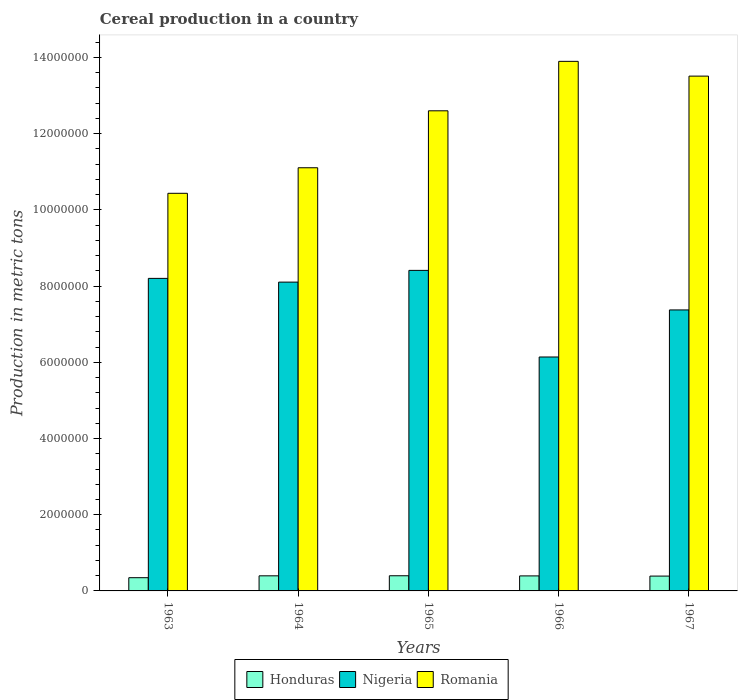Are the number of bars per tick equal to the number of legend labels?
Provide a succinct answer. Yes. Are the number of bars on each tick of the X-axis equal?
Make the answer very short. Yes. How many bars are there on the 5th tick from the left?
Offer a very short reply. 3. What is the total cereal production in Nigeria in 1963?
Your answer should be compact. 8.20e+06. Across all years, what is the maximum total cereal production in Nigeria?
Offer a very short reply. 8.41e+06. Across all years, what is the minimum total cereal production in Honduras?
Offer a very short reply. 3.47e+05. In which year was the total cereal production in Romania maximum?
Give a very brief answer. 1966. In which year was the total cereal production in Honduras minimum?
Your answer should be very brief. 1963. What is the total total cereal production in Honduras in the graph?
Provide a succinct answer. 1.93e+06. What is the difference between the total cereal production in Romania in 1964 and that in 1967?
Make the answer very short. -2.40e+06. What is the difference between the total cereal production in Nigeria in 1965 and the total cereal production in Honduras in 1963?
Make the answer very short. 8.07e+06. What is the average total cereal production in Nigeria per year?
Offer a terse response. 7.65e+06. In the year 1967, what is the difference between the total cereal production in Honduras and total cereal production in Nigeria?
Give a very brief answer. -6.99e+06. What is the ratio of the total cereal production in Honduras in 1965 to that in 1967?
Provide a succinct answer. 1.02. Is the difference between the total cereal production in Honduras in 1966 and 1967 greater than the difference between the total cereal production in Nigeria in 1966 and 1967?
Ensure brevity in your answer.  Yes. What is the difference between the highest and the second highest total cereal production in Honduras?
Provide a succinct answer. 1847. What is the difference between the highest and the lowest total cereal production in Nigeria?
Ensure brevity in your answer.  2.27e+06. In how many years, is the total cereal production in Honduras greater than the average total cereal production in Honduras taken over all years?
Offer a terse response. 4. What does the 3rd bar from the left in 1967 represents?
Provide a succinct answer. Romania. What does the 2nd bar from the right in 1964 represents?
Provide a short and direct response. Nigeria. Are all the bars in the graph horizontal?
Offer a terse response. No. Are the values on the major ticks of Y-axis written in scientific E-notation?
Ensure brevity in your answer.  No. How many legend labels are there?
Your answer should be compact. 3. What is the title of the graph?
Offer a very short reply. Cereal production in a country. Does "Mozambique" appear as one of the legend labels in the graph?
Your answer should be very brief. No. What is the label or title of the X-axis?
Offer a very short reply. Years. What is the label or title of the Y-axis?
Provide a succinct answer. Production in metric tons. What is the Production in metric tons of Honduras in 1963?
Provide a succinct answer. 3.47e+05. What is the Production in metric tons of Nigeria in 1963?
Provide a succinct answer. 8.20e+06. What is the Production in metric tons of Romania in 1963?
Offer a very short reply. 1.04e+07. What is the Production in metric tons of Honduras in 1964?
Provide a succinct answer. 3.96e+05. What is the Production in metric tons of Nigeria in 1964?
Keep it short and to the point. 8.10e+06. What is the Production in metric tons in Romania in 1964?
Make the answer very short. 1.11e+07. What is the Production in metric tons of Honduras in 1965?
Offer a very short reply. 3.98e+05. What is the Production in metric tons in Nigeria in 1965?
Your answer should be very brief. 8.41e+06. What is the Production in metric tons in Romania in 1965?
Ensure brevity in your answer.  1.26e+07. What is the Production in metric tons of Honduras in 1966?
Provide a succinct answer. 3.94e+05. What is the Production in metric tons of Nigeria in 1966?
Ensure brevity in your answer.  6.14e+06. What is the Production in metric tons of Romania in 1966?
Offer a terse response. 1.39e+07. What is the Production in metric tons of Honduras in 1967?
Your answer should be compact. 3.89e+05. What is the Production in metric tons of Nigeria in 1967?
Your answer should be very brief. 7.38e+06. What is the Production in metric tons in Romania in 1967?
Provide a short and direct response. 1.35e+07. Across all years, what is the maximum Production in metric tons in Honduras?
Offer a terse response. 3.98e+05. Across all years, what is the maximum Production in metric tons in Nigeria?
Provide a succinct answer. 8.41e+06. Across all years, what is the maximum Production in metric tons in Romania?
Offer a very short reply. 1.39e+07. Across all years, what is the minimum Production in metric tons in Honduras?
Provide a succinct answer. 3.47e+05. Across all years, what is the minimum Production in metric tons of Nigeria?
Make the answer very short. 6.14e+06. Across all years, what is the minimum Production in metric tons of Romania?
Ensure brevity in your answer.  1.04e+07. What is the total Production in metric tons of Honduras in the graph?
Provide a succinct answer. 1.93e+06. What is the total Production in metric tons in Nigeria in the graph?
Make the answer very short. 3.82e+07. What is the total Production in metric tons in Romania in the graph?
Ensure brevity in your answer.  6.16e+07. What is the difference between the Production in metric tons of Honduras in 1963 and that in 1964?
Offer a very short reply. -4.91e+04. What is the difference between the Production in metric tons of Nigeria in 1963 and that in 1964?
Provide a succinct answer. 9.80e+04. What is the difference between the Production in metric tons of Romania in 1963 and that in 1964?
Offer a terse response. -6.71e+05. What is the difference between the Production in metric tons of Honduras in 1963 and that in 1965?
Provide a short and direct response. -5.09e+04. What is the difference between the Production in metric tons in Nigeria in 1963 and that in 1965?
Ensure brevity in your answer.  -2.10e+05. What is the difference between the Production in metric tons in Romania in 1963 and that in 1965?
Give a very brief answer. -2.17e+06. What is the difference between the Production in metric tons in Honduras in 1963 and that in 1966?
Offer a terse response. -4.71e+04. What is the difference between the Production in metric tons of Nigeria in 1963 and that in 1966?
Your response must be concise. 2.06e+06. What is the difference between the Production in metric tons of Romania in 1963 and that in 1966?
Make the answer very short. -3.46e+06. What is the difference between the Production in metric tons in Honduras in 1963 and that in 1967?
Ensure brevity in your answer.  -4.22e+04. What is the difference between the Production in metric tons in Nigeria in 1963 and that in 1967?
Your answer should be very brief. 8.28e+05. What is the difference between the Production in metric tons of Romania in 1963 and that in 1967?
Give a very brief answer. -3.08e+06. What is the difference between the Production in metric tons of Honduras in 1964 and that in 1965?
Provide a short and direct response. -1847. What is the difference between the Production in metric tons of Nigeria in 1964 and that in 1965?
Offer a terse response. -3.08e+05. What is the difference between the Production in metric tons in Romania in 1964 and that in 1965?
Give a very brief answer. -1.49e+06. What is the difference between the Production in metric tons in Honduras in 1964 and that in 1966?
Your answer should be very brief. 1966. What is the difference between the Production in metric tons of Nigeria in 1964 and that in 1966?
Make the answer very short. 1.96e+06. What is the difference between the Production in metric tons in Romania in 1964 and that in 1966?
Offer a very short reply. -2.79e+06. What is the difference between the Production in metric tons of Honduras in 1964 and that in 1967?
Your response must be concise. 6882. What is the difference between the Production in metric tons in Nigeria in 1964 and that in 1967?
Your response must be concise. 7.30e+05. What is the difference between the Production in metric tons in Romania in 1964 and that in 1967?
Provide a short and direct response. -2.40e+06. What is the difference between the Production in metric tons in Honduras in 1965 and that in 1966?
Provide a succinct answer. 3813. What is the difference between the Production in metric tons in Nigeria in 1965 and that in 1966?
Your response must be concise. 2.27e+06. What is the difference between the Production in metric tons of Romania in 1965 and that in 1966?
Ensure brevity in your answer.  -1.30e+06. What is the difference between the Production in metric tons in Honduras in 1965 and that in 1967?
Ensure brevity in your answer.  8729. What is the difference between the Production in metric tons in Nigeria in 1965 and that in 1967?
Make the answer very short. 1.04e+06. What is the difference between the Production in metric tons of Romania in 1965 and that in 1967?
Offer a terse response. -9.10e+05. What is the difference between the Production in metric tons in Honduras in 1966 and that in 1967?
Offer a very short reply. 4916. What is the difference between the Production in metric tons in Nigeria in 1966 and that in 1967?
Your answer should be compact. -1.24e+06. What is the difference between the Production in metric tons of Romania in 1966 and that in 1967?
Offer a very short reply. 3.88e+05. What is the difference between the Production in metric tons of Honduras in 1963 and the Production in metric tons of Nigeria in 1964?
Your answer should be very brief. -7.76e+06. What is the difference between the Production in metric tons of Honduras in 1963 and the Production in metric tons of Romania in 1964?
Provide a short and direct response. -1.08e+07. What is the difference between the Production in metric tons in Nigeria in 1963 and the Production in metric tons in Romania in 1964?
Offer a terse response. -2.90e+06. What is the difference between the Production in metric tons of Honduras in 1963 and the Production in metric tons of Nigeria in 1965?
Keep it short and to the point. -8.07e+06. What is the difference between the Production in metric tons in Honduras in 1963 and the Production in metric tons in Romania in 1965?
Your response must be concise. -1.23e+07. What is the difference between the Production in metric tons of Nigeria in 1963 and the Production in metric tons of Romania in 1965?
Keep it short and to the point. -4.40e+06. What is the difference between the Production in metric tons of Honduras in 1963 and the Production in metric tons of Nigeria in 1966?
Your answer should be compact. -5.79e+06. What is the difference between the Production in metric tons of Honduras in 1963 and the Production in metric tons of Romania in 1966?
Offer a terse response. -1.36e+07. What is the difference between the Production in metric tons in Nigeria in 1963 and the Production in metric tons in Romania in 1966?
Offer a very short reply. -5.70e+06. What is the difference between the Production in metric tons of Honduras in 1963 and the Production in metric tons of Nigeria in 1967?
Give a very brief answer. -7.03e+06. What is the difference between the Production in metric tons in Honduras in 1963 and the Production in metric tons in Romania in 1967?
Ensure brevity in your answer.  -1.32e+07. What is the difference between the Production in metric tons of Nigeria in 1963 and the Production in metric tons of Romania in 1967?
Your answer should be compact. -5.31e+06. What is the difference between the Production in metric tons in Honduras in 1964 and the Production in metric tons in Nigeria in 1965?
Make the answer very short. -8.02e+06. What is the difference between the Production in metric tons of Honduras in 1964 and the Production in metric tons of Romania in 1965?
Offer a terse response. -1.22e+07. What is the difference between the Production in metric tons in Nigeria in 1964 and the Production in metric tons in Romania in 1965?
Your answer should be compact. -4.50e+06. What is the difference between the Production in metric tons in Honduras in 1964 and the Production in metric tons in Nigeria in 1966?
Provide a short and direct response. -5.74e+06. What is the difference between the Production in metric tons of Honduras in 1964 and the Production in metric tons of Romania in 1966?
Provide a short and direct response. -1.35e+07. What is the difference between the Production in metric tons of Nigeria in 1964 and the Production in metric tons of Romania in 1966?
Make the answer very short. -5.79e+06. What is the difference between the Production in metric tons of Honduras in 1964 and the Production in metric tons of Nigeria in 1967?
Your answer should be compact. -6.98e+06. What is the difference between the Production in metric tons in Honduras in 1964 and the Production in metric tons in Romania in 1967?
Your answer should be very brief. -1.31e+07. What is the difference between the Production in metric tons of Nigeria in 1964 and the Production in metric tons of Romania in 1967?
Give a very brief answer. -5.41e+06. What is the difference between the Production in metric tons in Honduras in 1965 and the Production in metric tons in Nigeria in 1966?
Your answer should be very brief. -5.74e+06. What is the difference between the Production in metric tons in Honduras in 1965 and the Production in metric tons in Romania in 1966?
Provide a short and direct response. -1.35e+07. What is the difference between the Production in metric tons of Nigeria in 1965 and the Production in metric tons of Romania in 1966?
Provide a succinct answer. -5.49e+06. What is the difference between the Production in metric tons of Honduras in 1965 and the Production in metric tons of Nigeria in 1967?
Give a very brief answer. -6.98e+06. What is the difference between the Production in metric tons of Honduras in 1965 and the Production in metric tons of Romania in 1967?
Your answer should be compact. -1.31e+07. What is the difference between the Production in metric tons of Nigeria in 1965 and the Production in metric tons of Romania in 1967?
Your answer should be very brief. -5.10e+06. What is the difference between the Production in metric tons of Honduras in 1966 and the Production in metric tons of Nigeria in 1967?
Ensure brevity in your answer.  -6.98e+06. What is the difference between the Production in metric tons of Honduras in 1966 and the Production in metric tons of Romania in 1967?
Ensure brevity in your answer.  -1.31e+07. What is the difference between the Production in metric tons of Nigeria in 1966 and the Production in metric tons of Romania in 1967?
Make the answer very short. -7.37e+06. What is the average Production in metric tons in Honduras per year?
Provide a short and direct response. 3.85e+05. What is the average Production in metric tons of Nigeria per year?
Your answer should be compact. 7.65e+06. What is the average Production in metric tons in Romania per year?
Give a very brief answer. 1.23e+07. In the year 1963, what is the difference between the Production in metric tons in Honduras and Production in metric tons in Nigeria?
Your answer should be compact. -7.86e+06. In the year 1963, what is the difference between the Production in metric tons in Honduras and Production in metric tons in Romania?
Ensure brevity in your answer.  -1.01e+07. In the year 1963, what is the difference between the Production in metric tons in Nigeria and Production in metric tons in Romania?
Your answer should be very brief. -2.23e+06. In the year 1964, what is the difference between the Production in metric tons in Honduras and Production in metric tons in Nigeria?
Make the answer very short. -7.71e+06. In the year 1964, what is the difference between the Production in metric tons in Honduras and Production in metric tons in Romania?
Provide a succinct answer. -1.07e+07. In the year 1964, what is the difference between the Production in metric tons in Nigeria and Production in metric tons in Romania?
Give a very brief answer. -3.00e+06. In the year 1965, what is the difference between the Production in metric tons in Honduras and Production in metric tons in Nigeria?
Your response must be concise. -8.01e+06. In the year 1965, what is the difference between the Production in metric tons of Honduras and Production in metric tons of Romania?
Provide a short and direct response. -1.22e+07. In the year 1965, what is the difference between the Production in metric tons of Nigeria and Production in metric tons of Romania?
Your answer should be very brief. -4.19e+06. In the year 1966, what is the difference between the Production in metric tons of Honduras and Production in metric tons of Nigeria?
Provide a succinct answer. -5.75e+06. In the year 1966, what is the difference between the Production in metric tons of Honduras and Production in metric tons of Romania?
Your response must be concise. -1.35e+07. In the year 1966, what is the difference between the Production in metric tons of Nigeria and Production in metric tons of Romania?
Offer a terse response. -7.76e+06. In the year 1967, what is the difference between the Production in metric tons of Honduras and Production in metric tons of Nigeria?
Ensure brevity in your answer.  -6.99e+06. In the year 1967, what is the difference between the Production in metric tons in Honduras and Production in metric tons in Romania?
Offer a terse response. -1.31e+07. In the year 1967, what is the difference between the Production in metric tons in Nigeria and Production in metric tons in Romania?
Give a very brief answer. -6.14e+06. What is the ratio of the Production in metric tons of Honduras in 1963 to that in 1964?
Provide a succinct answer. 0.88. What is the ratio of the Production in metric tons of Nigeria in 1963 to that in 1964?
Make the answer very short. 1.01. What is the ratio of the Production in metric tons of Romania in 1963 to that in 1964?
Make the answer very short. 0.94. What is the ratio of the Production in metric tons of Honduras in 1963 to that in 1965?
Your answer should be compact. 0.87. What is the ratio of the Production in metric tons in Romania in 1963 to that in 1965?
Offer a very short reply. 0.83. What is the ratio of the Production in metric tons in Honduras in 1963 to that in 1966?
Keep it short and to the point. 0.88. What is the ratio of the Production in metric tons of Nigeria in 1963 to that in 1966?
Provide a short and direct response. 1.34. What is the ratio of the Production in metric tons in Romania in 1963 to that in 1966?
Ensure brevity in your answer.  0.75. What is the ratio of the Production in metric tons of Honduras in 1963 to that in 1967?
Offer a very short reply. 0.89. What is the ratio of the Production in metric tons of Nigeria in 1963 to that in 1967?
Provide a short and direct response. 1.11. What is the ratio of the Production in metric tons of Romania in 1963 to that in 1967?
Give a very brief answer. 0.77. What is the ratio of the Production in metric tons in Nigeria in 1964 to that in 1965?
Ensure brevity in your answer.  0.96. What is the ratio of the Production in metric tons in Romania in 1964 to that in 1965?
Make the answer very short. 0.88. What is the ratio of the Production in metric tons of Nigeria in 1964 to that in 1966?
Give a very brief answer. 1.32. What is the ratio of the Production in metric tons of Romania in 1964 to that in 1966?
Offer a very short reply. 0.8. What is the ratio of the Production in metric tons of Honduras in 1964 to that in 1967?
Offer a very short reply. 1.02. What is the ratio of the Production in metric tons of Nigeria in 1964 to that in 1967?
Ensure brevity in your answer.  1.1. What is the ratio of the Production in metric tons of Romania in 1964 to that in 1967?
Offer a very short reply. 0.82. What is the ratio of the Production in metric tons of Honduras in 1965 to that in 1966?
Offer a terse response. 1.01. What is the ratio of the Production in metric tons of Nigeria in 1965 to that in 1966?
Your answer should be very brief. 1.37. What is the ratio of the Production in metric tons in Romania in 1965 to that in 1966?
Your answer should be very brief. 0.91. What is the ratio of the Production in metric tons in Honduras in 1965 to that in 1967?
Your answer should be compact. 1.02. What is the ratio of the Production in metric tons in Nigeria in 1965 to that in 1967?
Offer a terse response. 1.14. What is the ratio of the Production in metric tons in Romania in 1965 to that in 1967?
Ensure brevity in your answer.  0.93. What is the ratio of the Production in metric tons in Honduras in 1966 to that in 1967?
Offer a very short reply. 1.01. What is the ratio of the Production in metric tons of Nigeria in 1966 to that in 1967?
Your response must be concise. 0.83. What is the ratio of the Production in metric tons in Romania in 1966 to that in 1967?
Offer a terse response. 1.03. What is the difference between the highest and the second highest Production in metric tons in Honduras?
Make the answer very short. 1847. What is the difference between the highest and the second highest Production in metric tons of Romania?
Your answer should be very brief. 3.88e+05. What is the difference between the highest and the lowest Production in metric tons in Honduras?
Offer a terse response. 5.09e+04. What is the difference between the highest and the lowest Production in metric tons of Nigeria?
Make the answer very short. 2.27e+06. What is the difference between the highest and the lowest Production in metric tons of Romania?
Your response must be concise. 3.46e+06. 